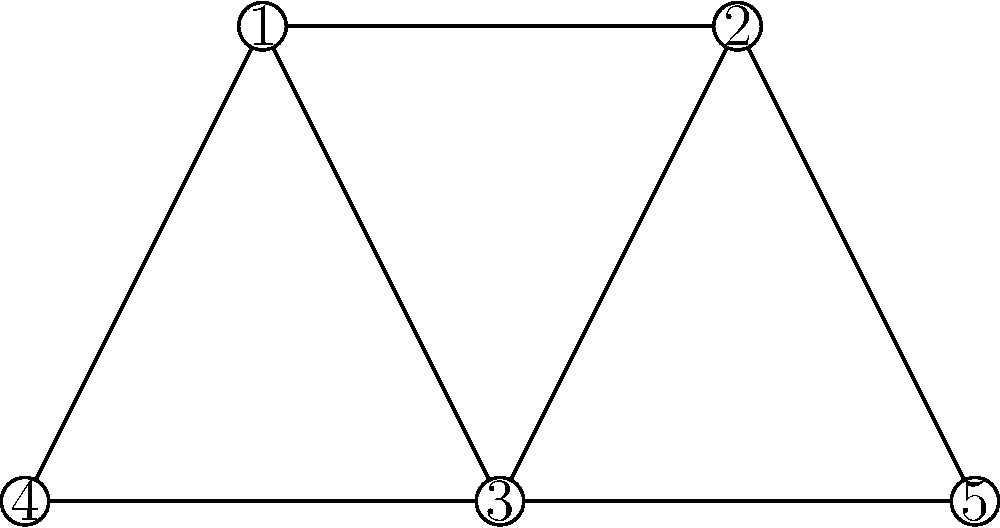In the given social network of terrorist organizations, which node has the highest betweenness centrality? Explain your reasoning based on the network structure and the implications for national security analysis. To determine the node with the highest betweenness centrality, we need to follow these steps:

1. Understand betweenness centrality: It measures the extent to which a node lies on the shortest paths between other nodes in the network.

2. Analyze the network structure:
   - The network has 5 nodes (1, 2, 3, 4, and 5).
   - Node 3 is connected to all other nodes except 5.
   - Nodes 1 and 2 are connected to each other and two other nodes.
   - Nodes 4 and 5 are only connected to two other nodes each.

3. Consider the shortest paths:
   - For paths between 1-2, 1-3, 1-4, 2-3, and 2-5, no other nodes lie between.
   - For paths between 1-5 and 2-4, node 3 lies on the shortest path.
   - For the path between 4-5, node 3 is the only connecting node.

4. Calculate betweenness centrality:
   - Node 3 lies on the most shortest paths (1-5, 2-4, 4-5).
   - Other nodes do not lie on any shortest paths between other pairs of nodes.

5. Implications for national security analysis:
   - The organization represented by node 3 acts as a crucial intermediary in the network.
   - Disrupting this organization could significantly impact the network's communication and operational capabilities.

Therefore, node 3 has the highest betweenness centrality in this terrorist organization network.
Answer: Node 3 